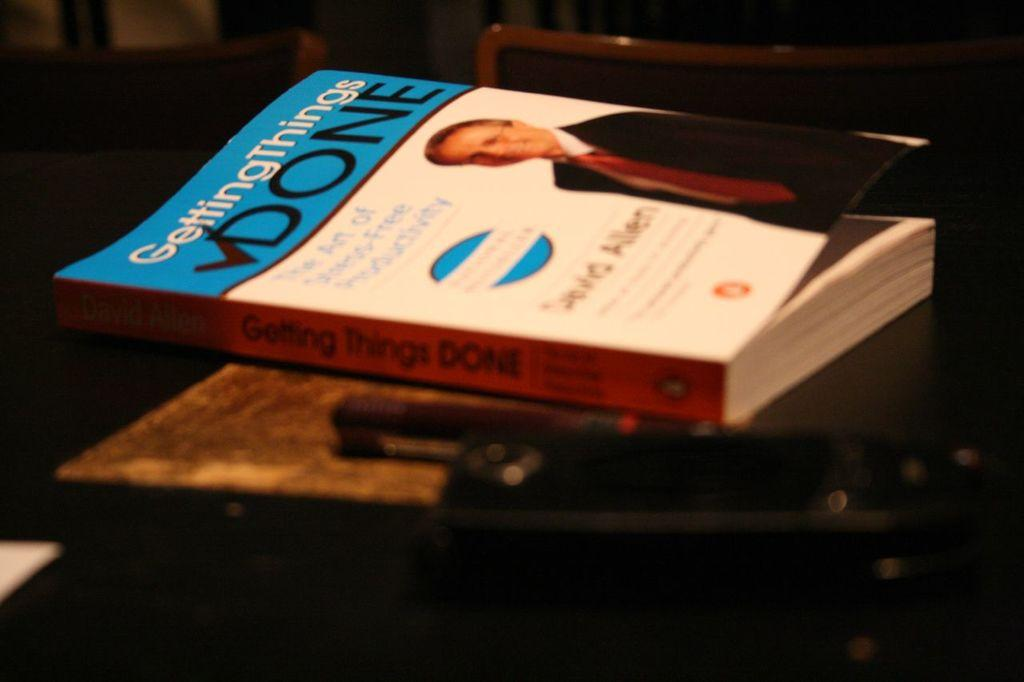<image>
Provide a brief description of the given image. a paperback copy of the book getting things done. 